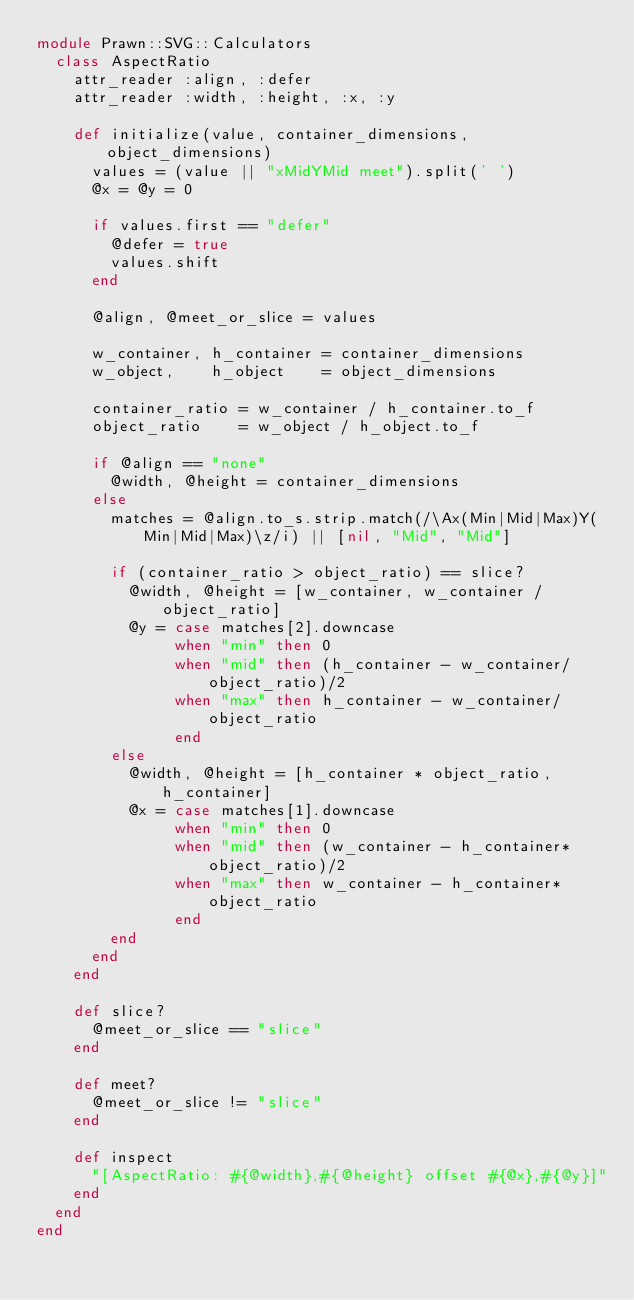Convert code to text. <code><loc_0><loc_0><loc_500><loc_500><_Ruby_>module Prawn::SVG::Calculators
  class AspectRatio
    attr_reader :align, :defer
    attr_reader :width, :height, :x, :y

    def initialize(value, container_dimensions, object_dimensions)
      values = (value || "xMidYMid meet").split(' ')
      @x = @y = 0

      if values.first == "defer"
        @defer = true
        values.shift
      end

      @align, @meet_or_slice = values

      w_container, h_container = container_dimensions
      w_object,    h_object    = object_dimensions

      container_ratio = w_container / h_container.to_f
      object_ratio    = w_object / h_object.to_f

      if @align == "none"
        @width, @height = container_dimensions
      else
        matches = @align.to_s.strip.match(/\Ax(Min|Mid|Max)Y(Min|Mid|Max)\z/i) || [nil, "Mid", "Mid"]

        if (container_ratio > object_ratio) == slice?
          @width, @height = [w_container, w_container / object_ratio]
          @y = case matches[2].downcase
               when "min" then 0
               when "mid" then (h_container - w_container/object_ratio)/2
               when "max" then h_container - w_container/object_ratio
               end
        else
          @width, @height = [h_container * object_ratio, h_container]
          @x = case matches[1].downcase
               when "min" then 0
               when "mid" then (w_container - h_container*object_ratio)/2
               when "max" then w_container - h_container*object_ratio
               end
        end
      end
    end

    def slice?
      @meet_or_slice == "slice"
    end

    def meet?
      @meet_or_slice != "slice"
    end

    def inspect
      "[AspectRatio: #{@width},#{@height} offset #{@x},#{@y}]"
    end
  end
end
</code> 